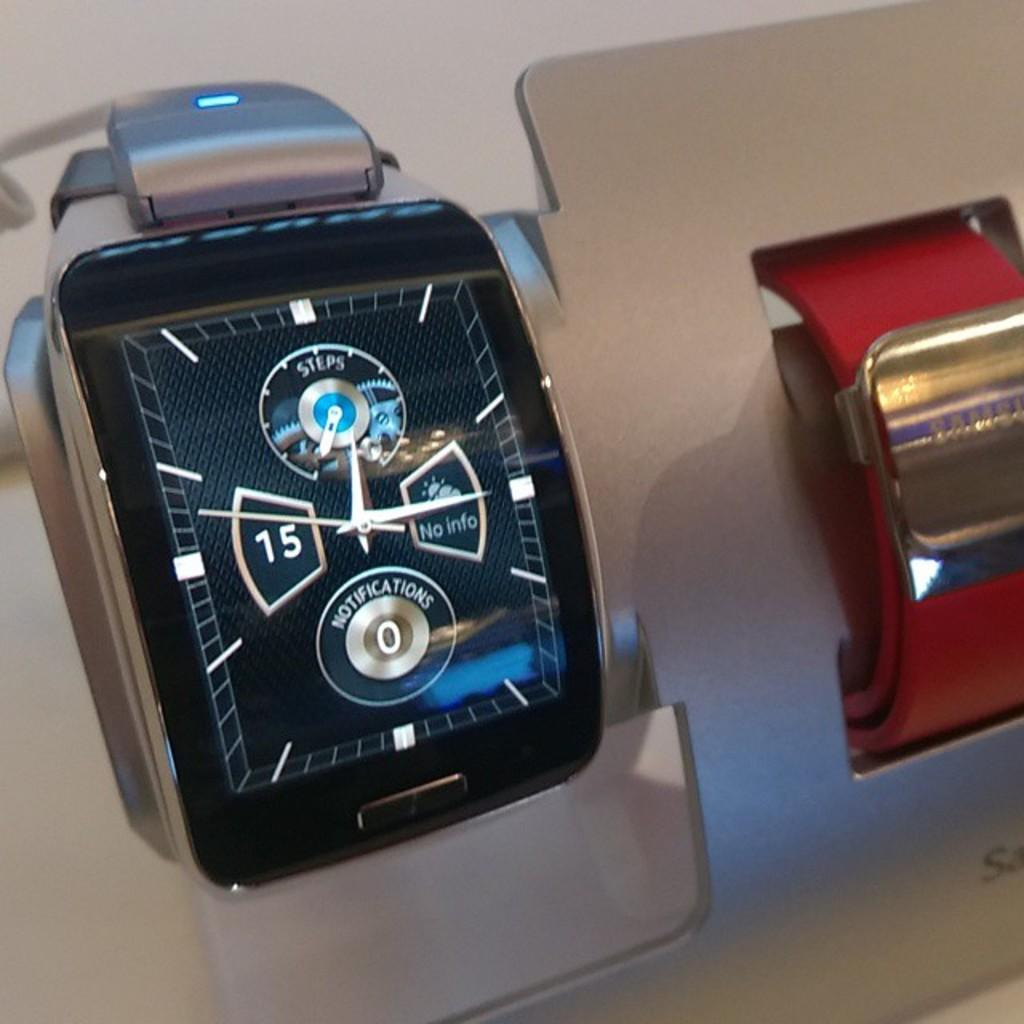<image>
Present a compact description of the photo's key features. A wrist watch features a display for steps and notifications. 